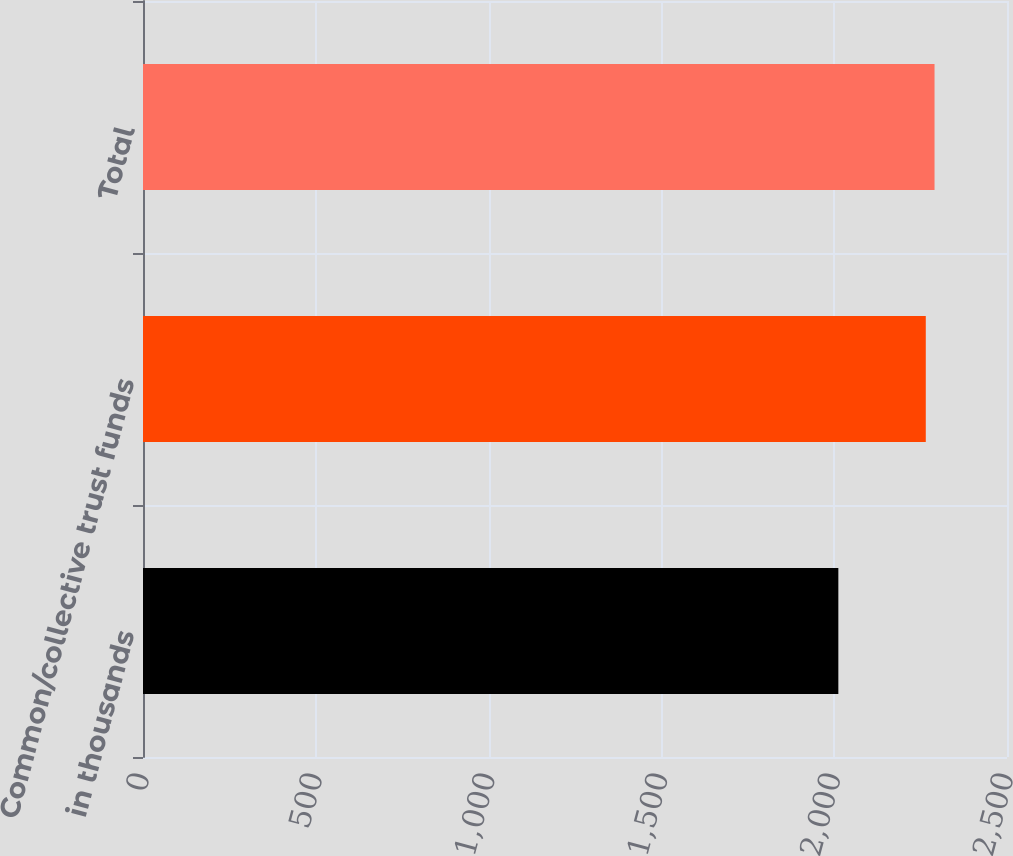Convert chart. <chart><loc_0><loc_0><loc_500><loc_500><bar_chart><fcel>in thousands<fcel>Common/collective trust funds<fcel>Total<nl><fcel>2012<fcel>2265<fcel>2290.3<nl></chart> 